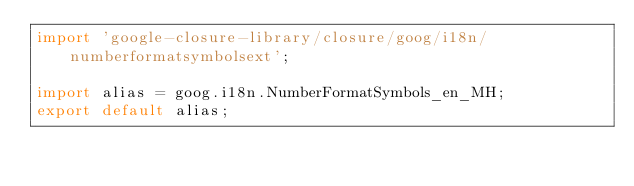<code> <loc_0><loc_0><loc_500><loc_500><_TypeScript_>import 'google-closure-library/closure/goog/i18n/numberformatsymbolsext';

import alias = goog.i18n.NumberFormatSymbols_en_MH;
export default alias;
</code> 